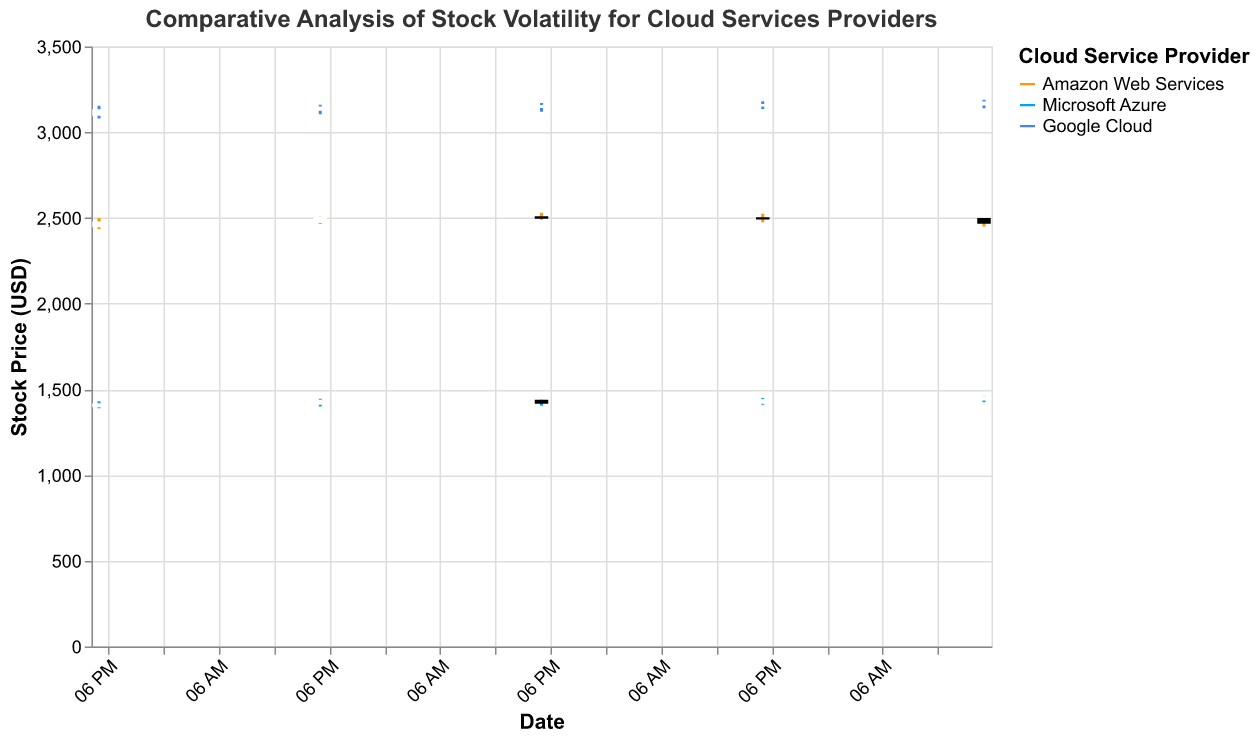What is the title of the plot? The title is usually displayed prominently at the top of the plot.
Answer: Comparative Analysis of Stock Volatility for Cloud Services Providers Which company had the highest opening stock price on October 1, 2023? By examining the "Open" values for each company on October 1, 2023, you can determine that Google Cloud had the highest opening stock price with 3100.
Answer: Google Cloud How did the closing price of Microsoft Azure change from October 2, 2023, to October 3, 2023? Compare the "Close" values for Microsoft Azure on October 2 (1435) and October 3 (1420). The difference shows a decrease of 15.
Answer: Decreased by 15 Among Amazon Web Services, Microsoft Azure, and Google Cloud, which company had the highest trading volume on October 4, 2023? Compare the volume data on October 4, 2023. Google Cloud had the highest volume with 4200000.
Answer: Google Cloud Which stock showed the greatest high-to-low range on October 5, 2023? To find the greatest range, subtract the "Low" value from the "High" value for each company on October 5. Google Cloud had the highest range of 50 points (3190 - 3140).
Answer: Google Cloud What was the overall trend in the closing price for Amazon Web Services from October 1 to October 5, 2023? Examine the closing prices for Amazon Web Services from October 1 (2475), October 2 (2505), October 3 (2500), October 4 (2495), and October 5 (2470). The trend shows a minor increase initially followed by a decrease.
Answer: Fluctuating with minor increase then decrease Compare the opening prices of Google Cloud and Microsoft Azure on October 3, 2023. Which was higher? Look at the opening prices for Google Cloud (3145) and Microsoft Azure (1435) on October 3, 2023. Google Cloud's opening price was higher.
Answer: Google Cloud What is the color used to represent Microsoft Azure in the plot? Identify the color associated with Microsoft Azure in the legend of the plot.
Answer: Light Blue Calculate the average closing price of Microsoft Azure from October 1 to October 5, 2023. Sum the closing prices from October 1 (1415), October 2 (1435), October 3 (1420), October 4 (1440), and October 5 (1455) and divide by 5. The calculation is (1415 + 1435 + 1420 + 1440 + 1455) / 5 = 1433.
Answer: 1433 What can be inferred about the volatility of Google Cloud's stock from the candlestick plot? Volatility can be inferred from the differences between the high and low prices represented by the length of the candlestick wicks. Google Cloud shows relatively high volatility with substantial differences between high and low prices each day.
Answer: High volatility 